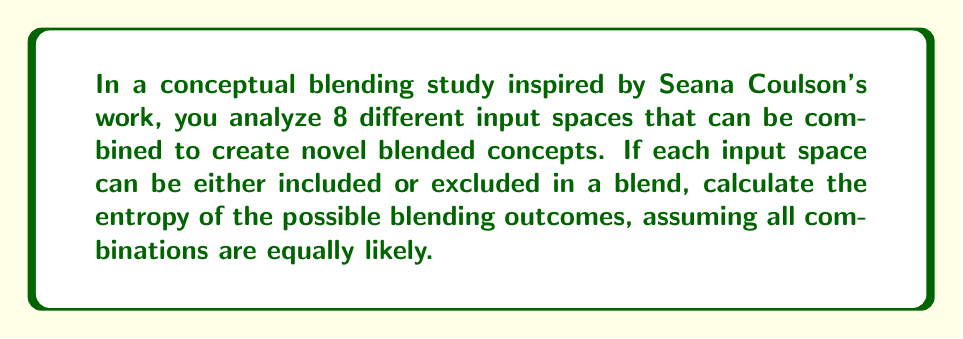Could you help me with this problem? To solve this problem, we'll follow these steps:

1) First, let's determine the number of possible outcomes. With 8 input spaces, each of which can be included or excluded, we have $2^8 = 256$ possible blending outcomes.

2) Since all combinations are equally likely, the probability of each outcome is:

   $p = \frac{1}{256}$

3) The entropy formula for a discrete probability distribution is:

   $H = -\sum_{i=1}^{n} p_i \log_2(p_i)$

   where $p_i$ is the probability of each outcome and $n$ is the number of possible outcomes.

4) In this case, all probabilities are equal, so we can simplify:

   $H = -n \cdot p \log_2(p)$

   where $n = 256$ and $p = \frac{1}{256}$

5) Substituting these values:

   $H = -256 \cdot \frac{1}{256} \log_2(\frac{1}{256})$

6) Simplify:

   $H = -\log_2(\frac{1}{256})$

7) Using the logarithm property $\log_a(\frac{1}{x}) = -\log_a(x)$:

   $H = \log_2(256)$

8) Since $256 = 2^8$:

   $H = \log_2(2^8) = 8$

Therefore, the entropy of the blending outcomes is 8 bits.
Answer: 8 bits 